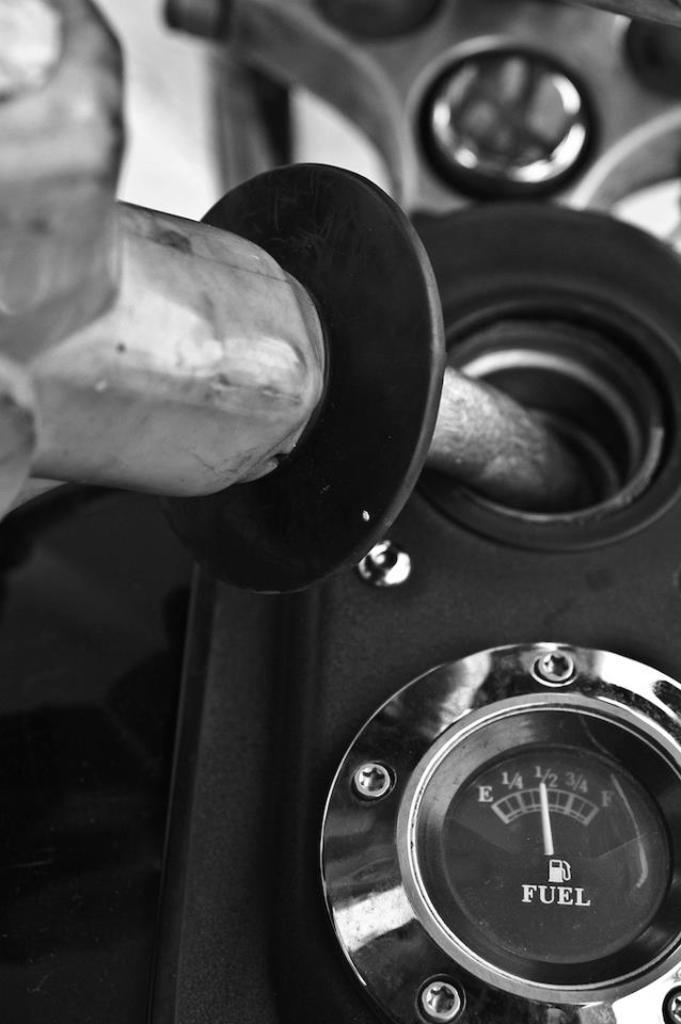What is the color scheme of the image? The image is black and white. What can be seen inside the motor vehicle in the image? There is a pipe in a motor vehicle in the image. What instrument is used to measure fuel in the image? There is a fuel gauge in the image. What type of quill is used to write on the fuel gauge in the image? There is no quill present in the image, and the fuel gauge is not a surface for writing. 